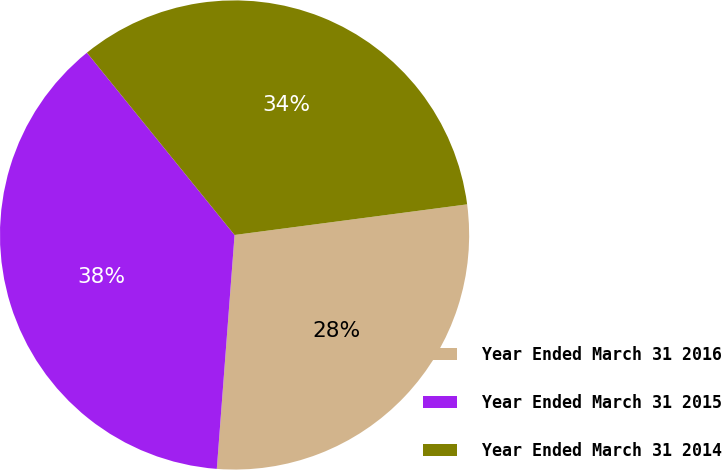Convert chart. <chart><loc_0><loc_0><loc_500><loc_500><pie_chart><fcel>Year Ended March 31 2016<fcel>Year Ended March 31 2015<fcel>Year Ended March 31 2014<nl><fcel>28.29%<fcel>37.96%<fcel>33.75%<nl></chart> 